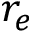<formula> <loc_0><loc_0><loc_500><loc_500>r _ { e }</formula> 